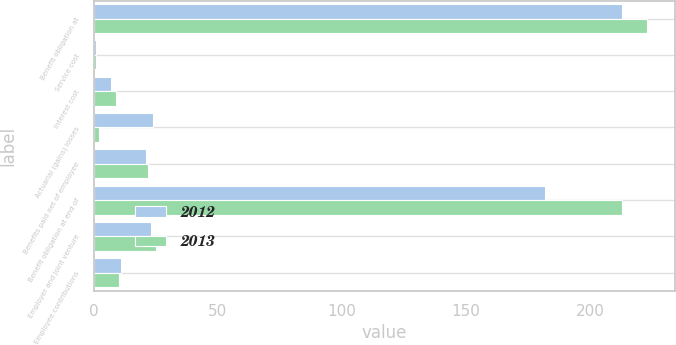Convert chart. <chart><loc_0><loc_0><loc_500><loc_500><stacked_bar_chart><ecel><fcel>Benefit obligation at<fcel>Service cost<fcel>Interest cost<fcel>Actuarial (gains) losses<fcel>Benefits paid net of employee<fcel>Benefit obligation at end of<fcel>Employer and joint venture<fcel>Employee contributions<nl><fcel>2012<fcel>213<fcel>1<fcel>7<fcel>24<fcel>21<fcel>182<fcel>23<fcel>11<nl><fcel>2013<fcel>223<fcel>1<fcel>9<fcel>2<fcel>22<fcel>213<fcel>25<fcel>10<nl></chart> 